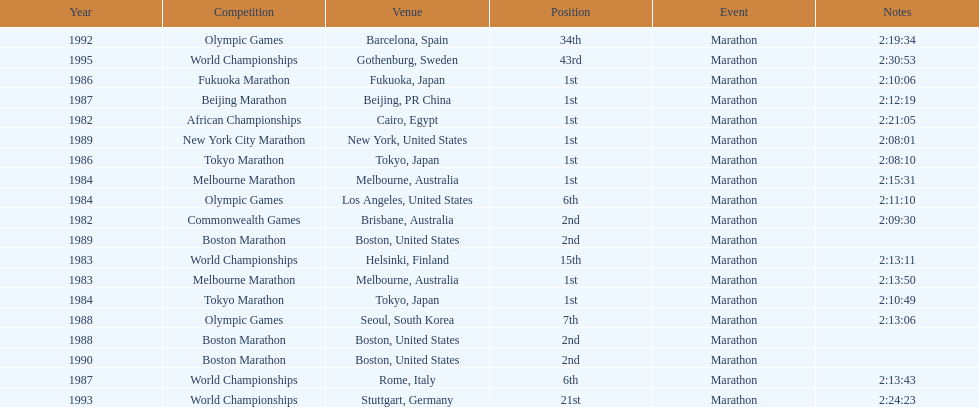What was the first marathon juma ikangaa won? 1982 African Championships. 